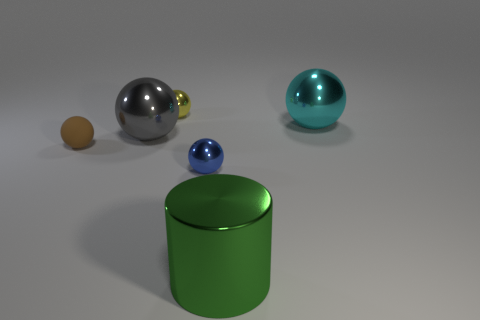Add 4 small green metal objects. How many objects exist? 10 Subtract all balls. How many objects are left? 1 Subtract all tiny cyan balls. Subtract all big green shiny things. How many objects are left? 5 Add 1 large green objects. How many large green objects are left? 2 Add 3 red balls. How many red balls exist? 3 Subtract all yellow balls. How many balls are left? 4 Subtract all tiny blue metallic spheres. How many spheres are left? 4 Subtract 0 blue blocks. How many objects are left? 6 Subtract 1 cylinders. How many cylinders are left? 0 Subtract all red cylinders. Subtract all yellow spheres. How many cylinders are left? 1 